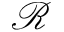Convert formula to latex. <formula><loc_0><loc_0><loc_500><loc_500>\mathcal { R }</formula> 